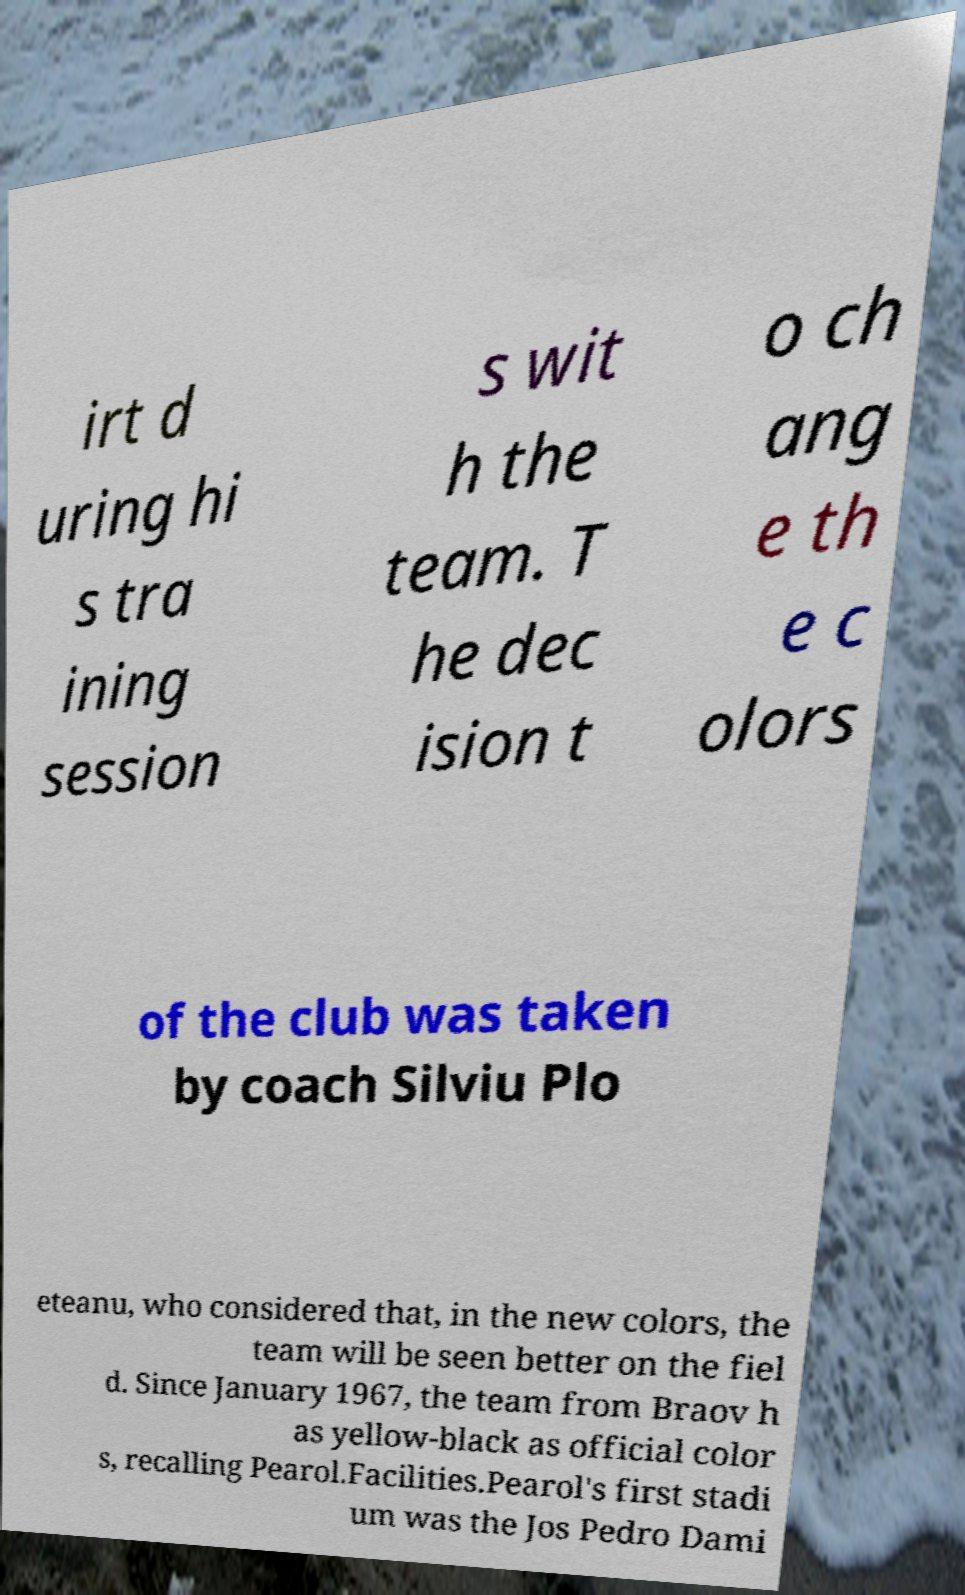Could you extract and type out the text from this image? irt d uring hi s tra ining session s wit h the team. T he dec ision t o ch ang e th e c olors of the club was taken by coach Silviu Plo eteanu, who considered that, in the new colors, the team will be seen better on the fiel d. Since January 1967, the team from Braov h as yellow-black as official color s, recalling Pearol.Facilities.Pearol's first stadi um was the Jos Pedro Dami 